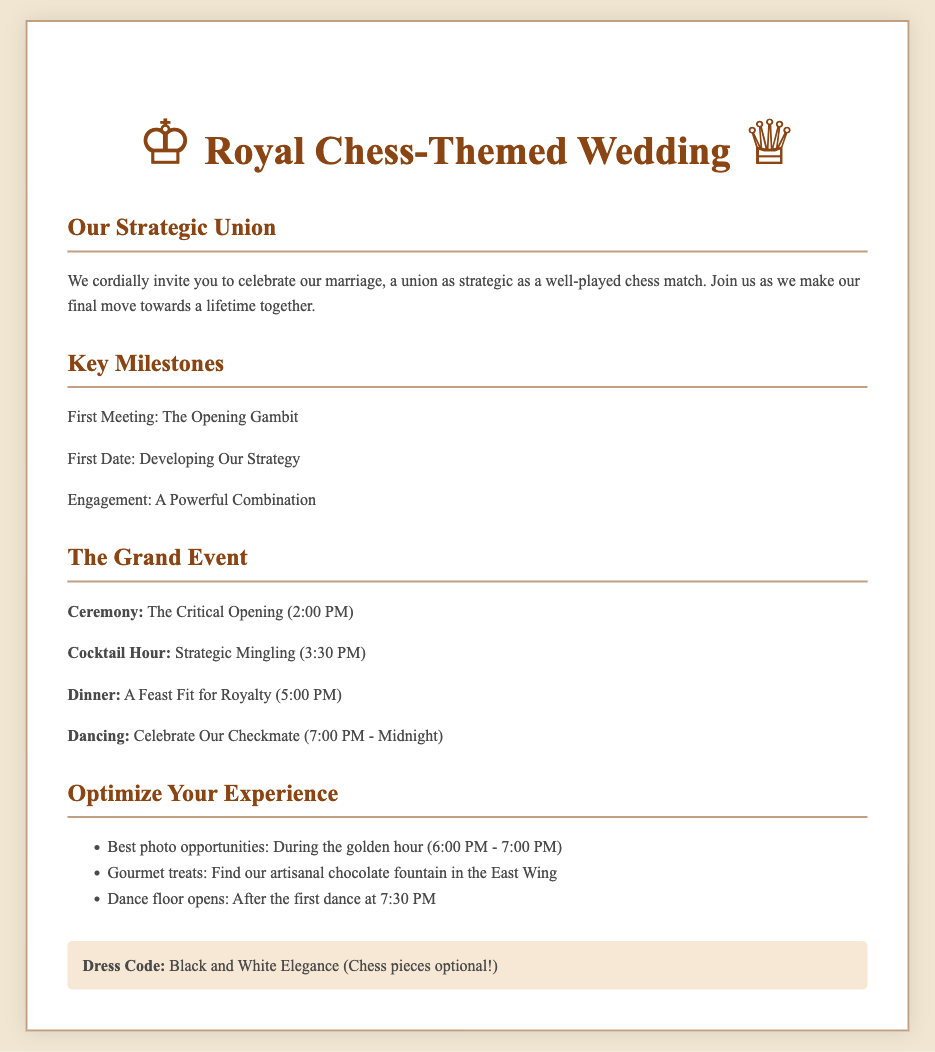What is the theme of the wedding invitation? The wedding invitation utilizes a chess theme, as indicated by references to chess terminology throughout the document.
Answer: Chess-themed What time does the ceremony begin? The document specifies the start time of the ceremony, which is stated as 2:00 PM.
Answer: 2:00 PM What is the dress code for the wedding? The invitation explicitly states the dress code requirements, specifically mentioning "Black and White Elegance."
Answer: Black and White Elegance What milestone is referred to as "The Critical Opening"? The timing of the ceremony correlates with the metaphorical description used in the document for this specific event.
Answer: Ceremony Which milestone is labeled "A Powerful Combination"? This phrase refers to a significant step in the couple's relationship, which is highlighted in the key milestones section of the document.
Answer: Engagement What is noted as the best time for photographs? The invitation suggests the golden hour for capturing photos, indicated within the optimize your experience section.
Answer: 6:00 PM - 7:00 PM What activity is scheduled to take place at 3:30 PM? The specific timing for this activity is provided in the event timeline of the wedding day, which hints at social engagement amongst guests.
Answer: Strategic Mingling How is the reception described in the invitation? The reception is presented in the document using chess-related language to enhance the thematic experience, particularly in the event schedule.
Answer: Celebrate Our Checkmate 